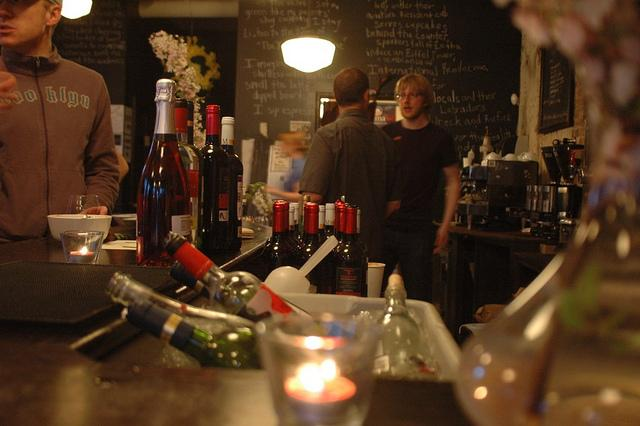Where are these people located?

Choices:
A) restaurant
B) classroom
C) office
D) theater restaurant 